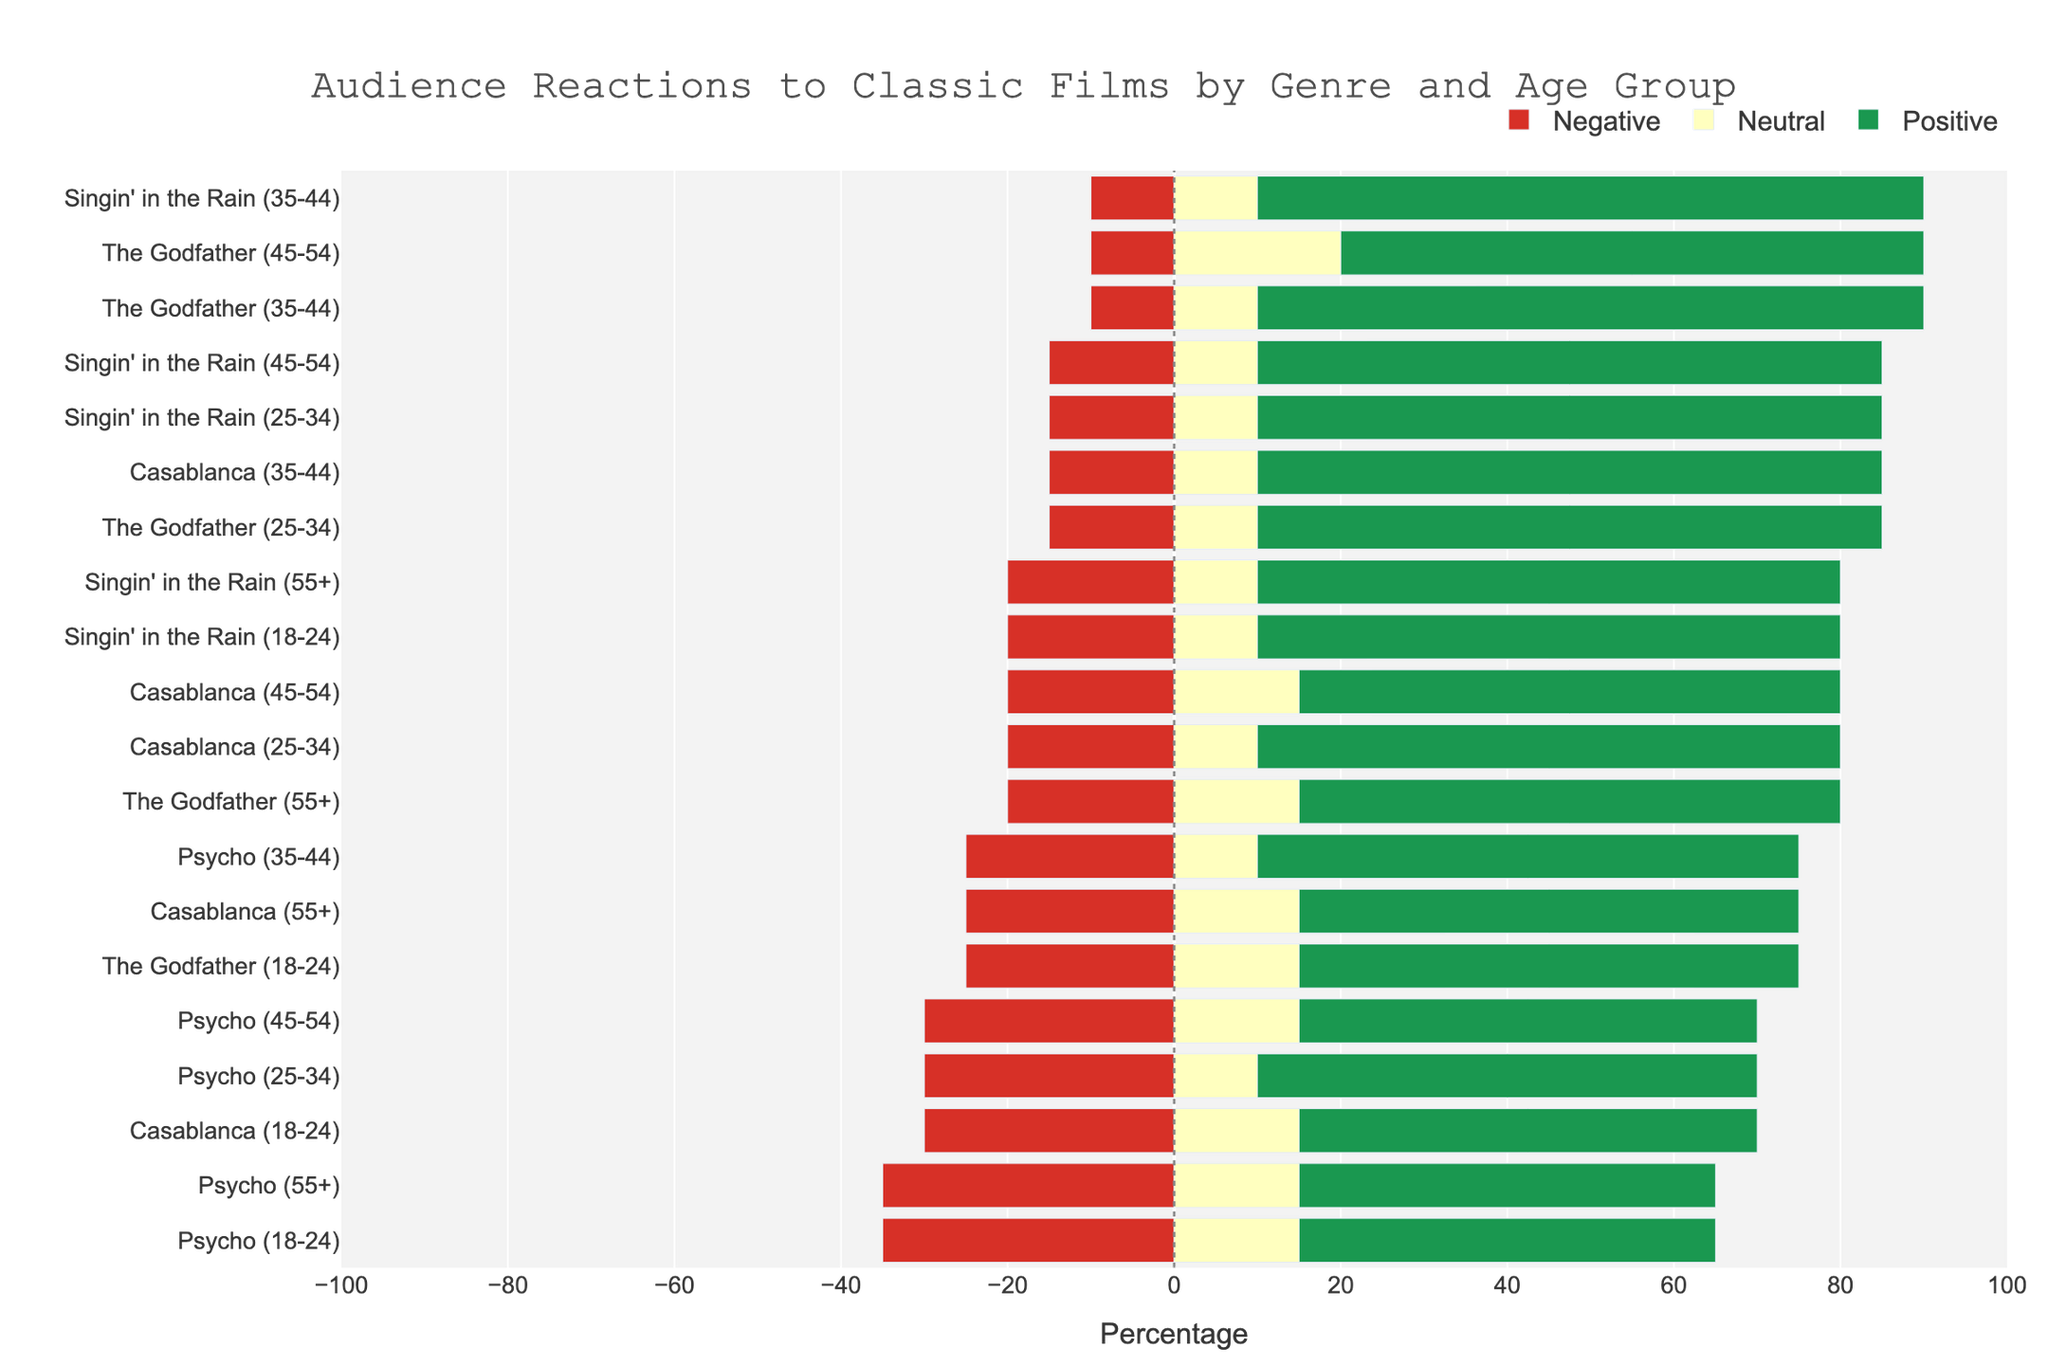What are the positive reactions like for "Singin' in the Rain" among the age group 35-44? Look at the bar corresponding to "Singin' in the Rain" for the age group 35-44 on the chart. The positive reactions bar should be in green and point to the right.
Answer: 80% Which age group has the most negative reaction to "Psycho"? Compare the length of the red (negative reactions) bars corresponding to the different age groups for "Psycho". The longest red bar indicates the highest negative reaction.
Answer: 18-24 How do the positive reactions to "The Godfather" differ between the age groups 18-24 and 25-34? Compare the green bars (positive reactions) for "The Godfather" between the age groups 18-24 and 25-34. The bar sizes indicate the percentage of positive reactions.
Answer: 75% - 60% = 15% Which film receives the least neutral reaction among the age 55+ group? For the age group 55+, compare the yellow (neutral reactions) bars across all films. The shortest yellow bar indicates the smallest neutral reaction percentage.
Answer: Singin' in the Rain What is the overall trend for neutral reactions across all films for the age group 45-54? Look at the yellow bars for all films in the age group 45-54. Assess whether they seem to be high, medium, or low in comparison to other age groups.
Answer: Medium Between "Casablanca" and "Singin' in the Rain", which film has a higher positive reaction among the age group 25-34? Compare the lengths of the green (positive reactions) bars for the age group 25-34 between "Casablanca" and "Singin' in the Rain". The longer bar indicates a higher positive reaction.
Answer: Singin' in the Rain What's the average negative reaction percentage for "The Godfather" across age groups? Sum the negative reaction percentages for "The Godfather" across all age groups and divide by the number of age groups (5). (25 + 15 + 10 + 10 + 20) / 5 = 80 / 5
Answer: 16% Visualizing the chart, which film generally has the most positive reactions across all age groups? Compare the lengths of the green bars (positive reactions) across all age groups and films. Observe which film seems to have consistently longer green bars.
Answer: Singin' in the Rain How does the neutral reaction percentage for "Casablanca" in age group 25-34 compare to the 55+ group? Compare the lengths of the yellow (neutral reactions) bars for "Casablanca" between the age groups 25-34 and 55+.
Answer: 10% vs 15% Is there an age group that generally has higher negative reactions to "Psycho"? Examine the lengths of the red (negative reactions) bars for "Psycho" across all age groups. Determine if one age group consistently has longer bars.
Answer: 18-24 